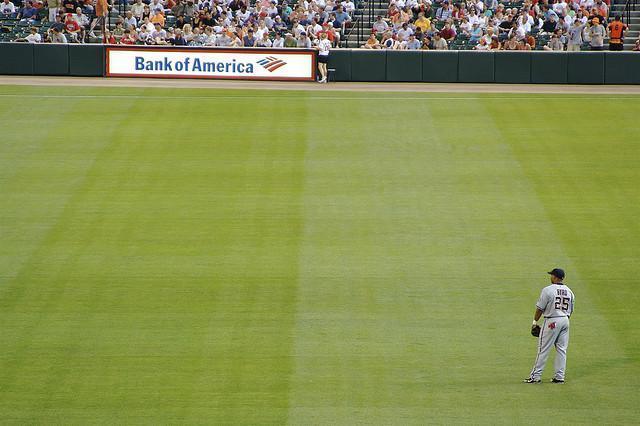How many people are on the field?
Give a very brief answer. 1. How many people are in the photo?
Give a very brief answer. 2. 